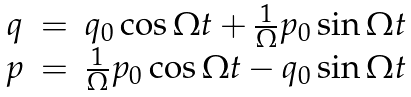Convert formula to latex. <formula><loc_0><loc_0><loc_500><loc_500>\begin{array} { c c l } q & = & q _ { 0 } \cos \Omega t + \frac { 1 } { \Omega } p _ { 0 } \sin \Omega t \\ p & = & \frac { 1 } { \Omega } p _ { 0 } \cos \Omega t - q _ { 0 } \sin \Omega t \end{array}</formula> 